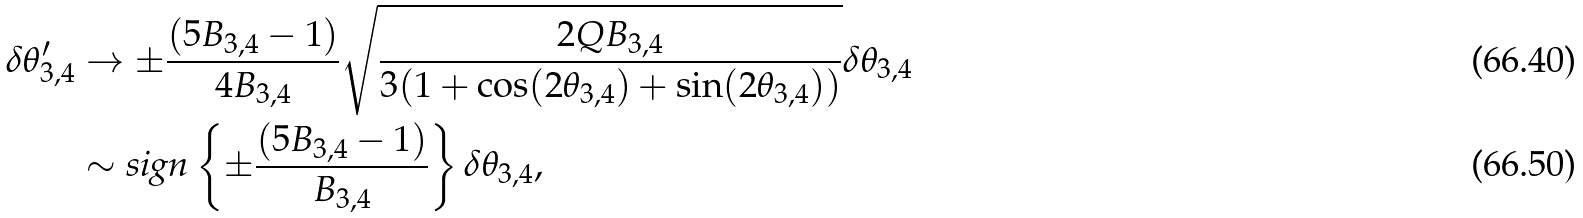Convert formula to latex. <formula><loc_0><loc_0><loc_500><loc_500>\delta \theta _ { 3 , 4 } ^ { \prime } & \rightarrow \pm \frac { ( 5 B _ { 3 , 4 } - 1 ) } { 4 B _ { 3 , 4 } } \sqrt { \frac { 2 Q B _ { 3 , 4 } } { 3 ( 1 + \cos ( 2 \theta _ { 3 , 4 } ) + \sin ( 2 \theta _ { 3 , 4 } ) ) } } \delta \theta _ { 3 , 4 } \\ & \sim \text {sign} \left \{ \pm \frac { ( 5 B _ { 3 , 4 } - 1 ) } { B _ { 3 , 4 } } \right \} \delta \theta _ { 3 , 4 } ,</formula> 